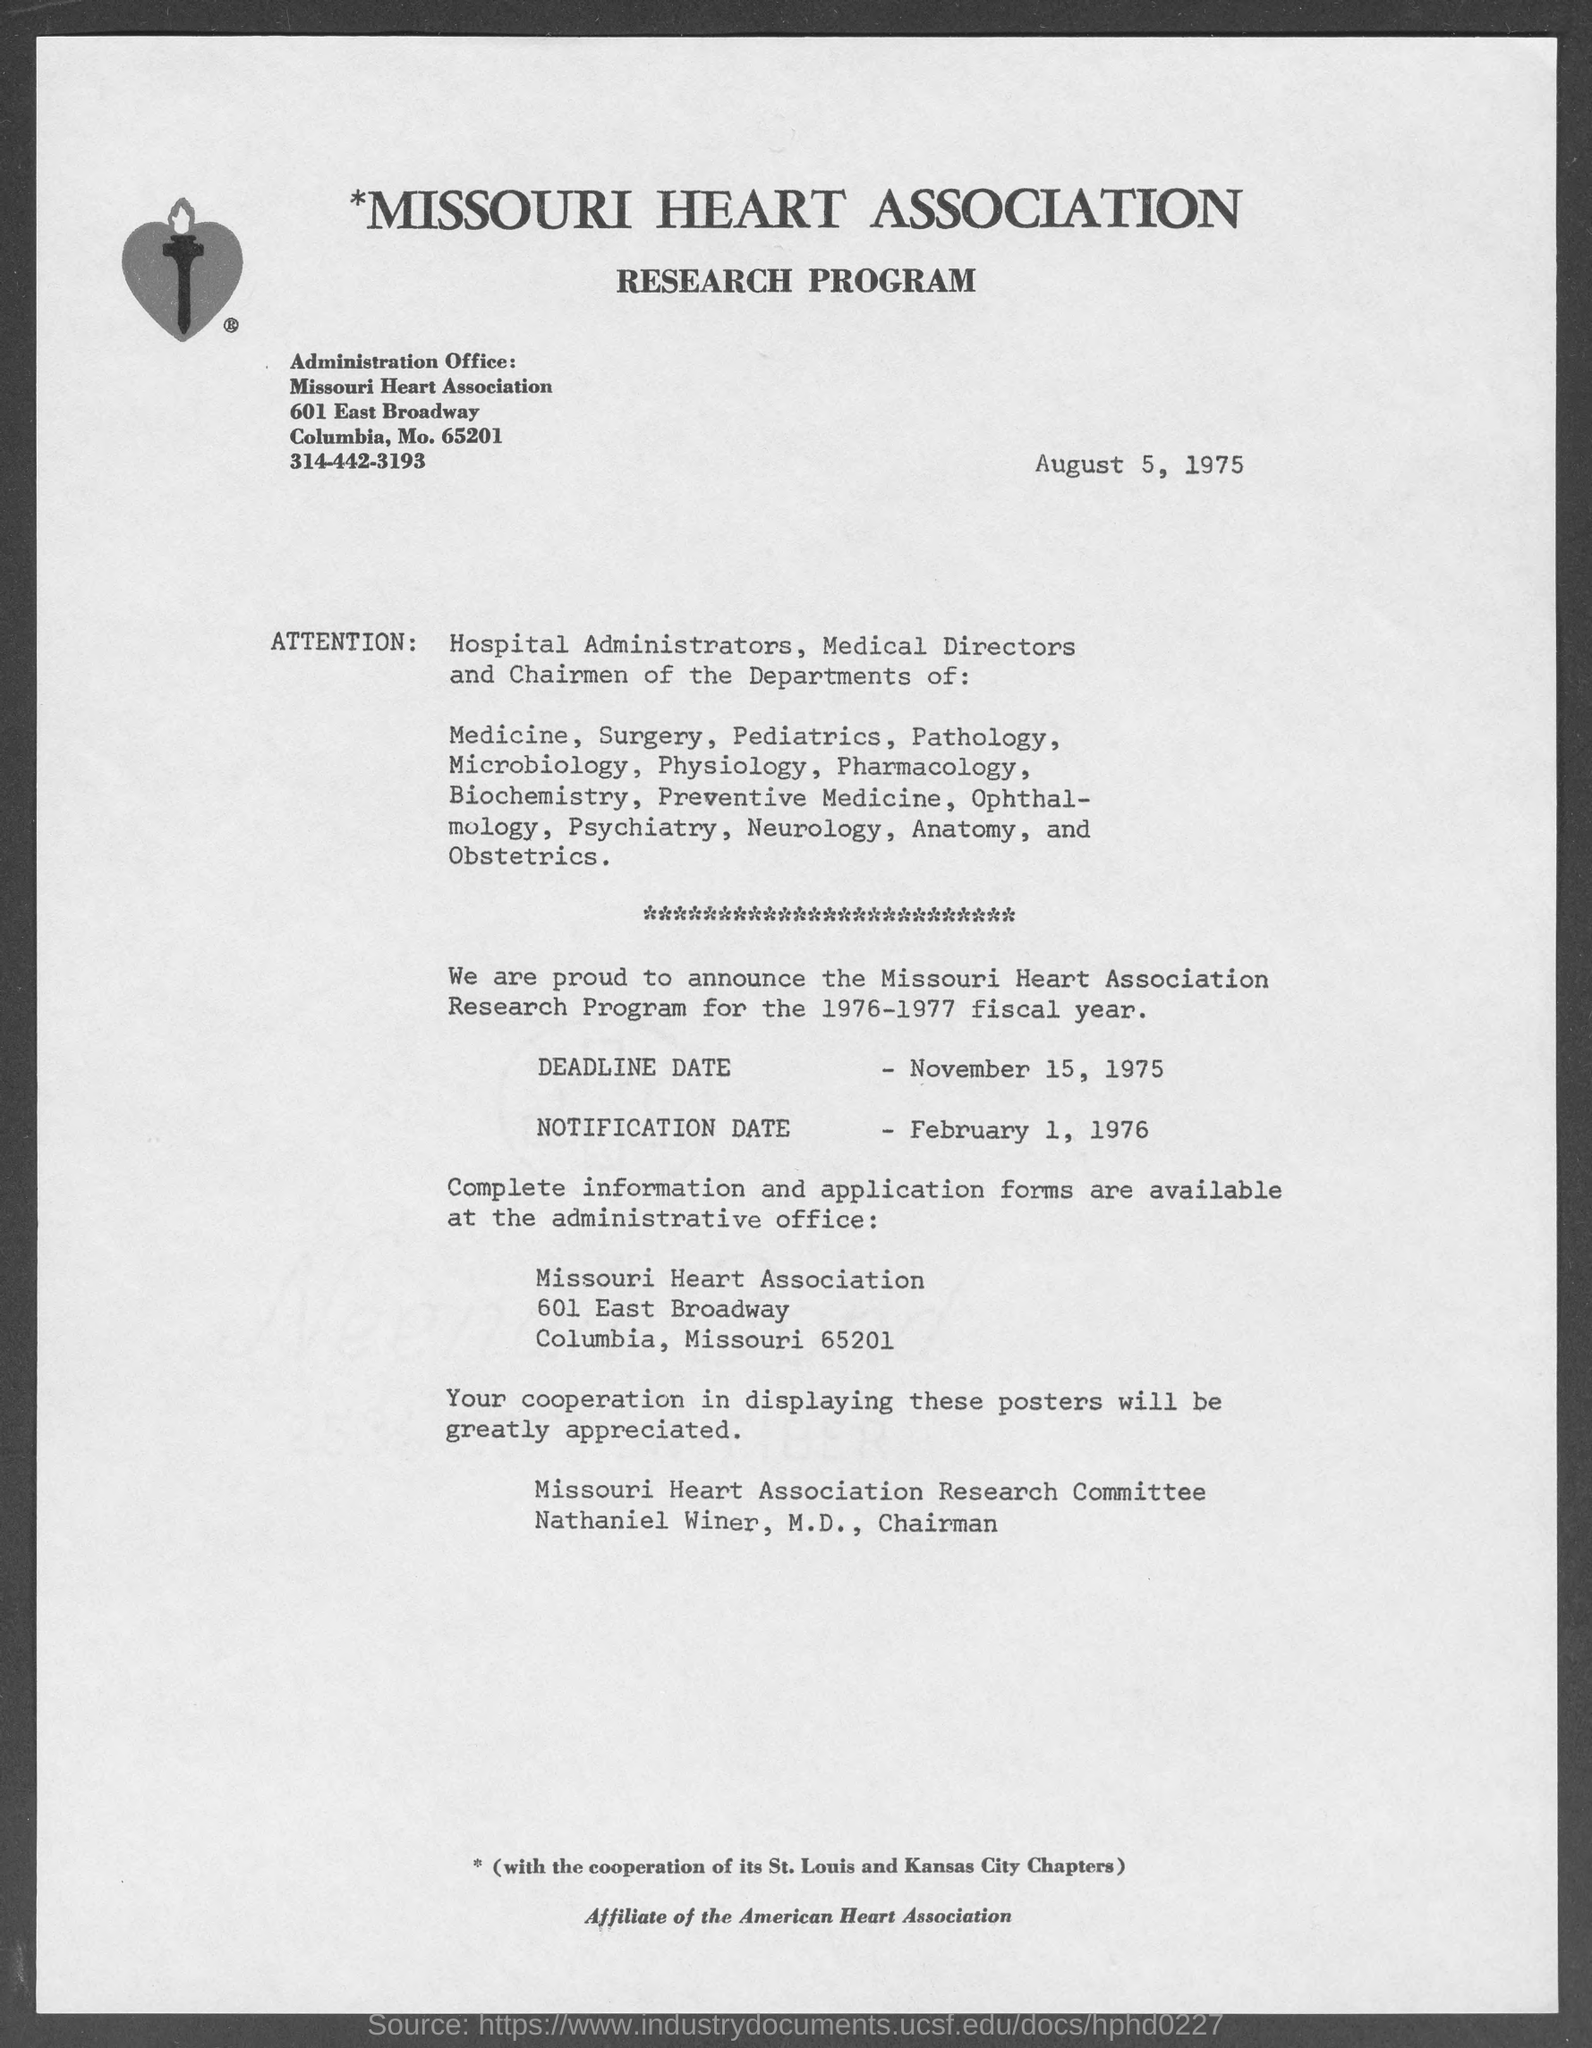Highlight a few significant elements in this photo. The notification date for the 1976-1977 fiscal year was February 1, 1976. Nathaniel Winer, M.D., is the chairman of the Missouri Heart Association Research Committee. The research program was posted on August 5, 1975. 